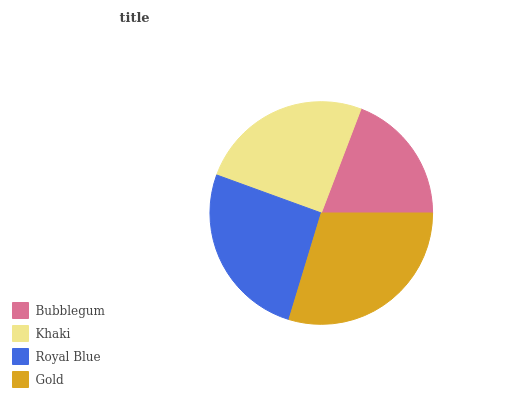Is Bubblegum the minimum?
Answer yes or no. Yes. Is Gold the maximum?
Answer yes or no. Yes. Is Khaki the minimum?
Answer yes or no. No. Is Khaki the maximum?
Answer yes or no. No. Is Khaki greater than Bubblegum?
Answer yes or no. Yes. Is Bubblegum less than Khaki?
Answer yes or no. Yes. Is Bubblegum greater than Khaki?
Answer yes or no. No. Is Khaki less than Bubblegum?
Answer yes or no. No. Is Royal Blue the high median?
Answer yes or no. Yes. Is Khaki the low median?
Answer yes or no. Yes. Is Gold the high median?
Answer yes or no. No. Is Bubblegum the low median?
Answer yes or no. No. 